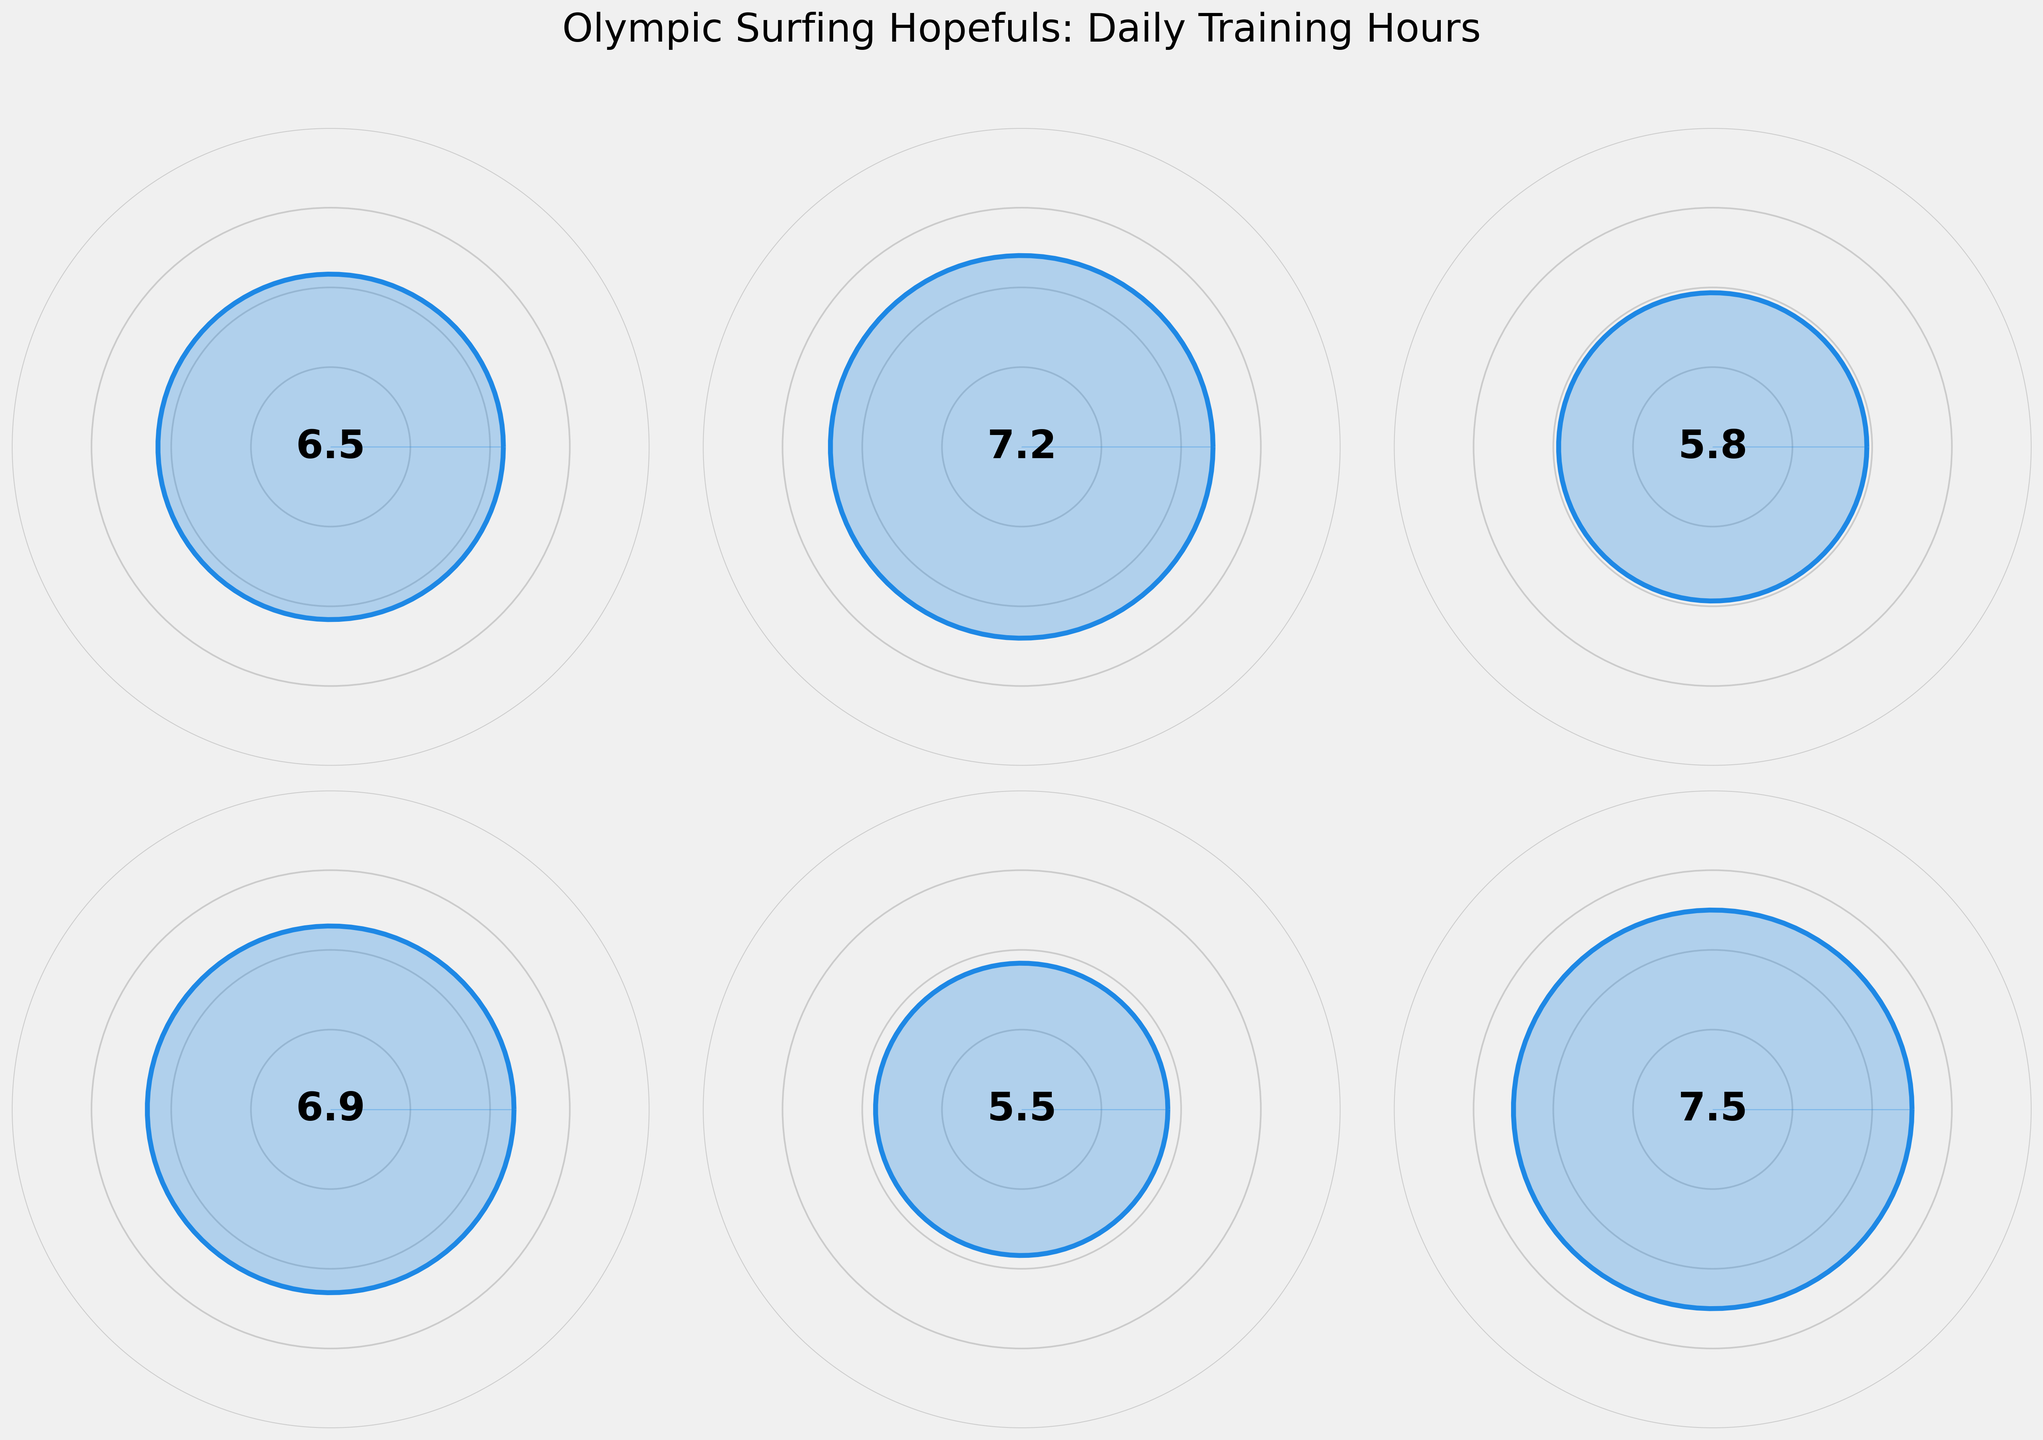What's the average daily training hours for the National Team? The figure shows the values for each team, including the National Team at 7.5 hours daily.
Answer: 7.5 What is the highest average daily training hours shown in the figure? By inspecting the different gauges, the highest value is for the National Team with 7.5 hours.
Answer: 7.5 Which team has the lowest average daily training hours? Comparing all the gauge values, Sydney Surf Academy has the lowest average training hours at 5.8.
Answer: 5.8 What is the difference in average daily training hours between the Gold Coast Elite Surfers and the Queensland Junior Team? The value for the Gold Coast Elite Surfers is 7.2, and for the Queensland Junior Team it is 5.5. The difference is 7.2 - 5.5.
Answer: 1.7 Which team has closer average daily training hours to the National Team, the Western Australia Squad or the Gold Coast Elite Surfers? The National Team averages 7.5 hours. The Western Australia Squad averages 6.9 hours, and the Gold Coast Elite Surfers average 7.2 hours. The difference for W.A. Squad is 0.6 hours, and for G.C. Elite Surfers, it’s 0.3 hours. Therefore, G.C. Elite Surfers are closer.
Answer: Gold Coast Elite Surfers How many teams have an average daily training hour of 6.5 or more? Inspect the gauge values: Gold Coast Elite Surfers (7.2), Western Australia Squad (6.9), National Team (7.5) all have values 6.5 or more. That makes 3 teams.
Answer: 3 What’s the range of values shown for all teams' average daily training hours? The highest value is 7.5 (National Team), and the lowest is 5.8 (Sydney Surf Academy), so the range is 7.5 - 5.8.
Answer: 1.7 Is the average daily training of the Western Australia Squad greater than that of Sydney Surf Academy? The value for Western Australia Squad is 6.9 and for Sydney Surf Academy is 5.8. Since 6.9 > 5.8, the Western Australia Squad trains more on average.
Answer: Yes Which two teams have the closest average daily training hours? Comparing all the values, the closest values are for Gold Coast Elite Surfers (7.2) and the National Team (7.5), with a difference of 0.3 hours.
Answer: Gold Coast Elite Surfers and National Team 